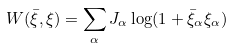<formula> <loc_0><loc_0><loc_500><loc_500>W ( \bar { \xi } , \xi ) = \sum _ { \alpha } J _ { \alpha } \log ( 1 + \bar { \xi } _ { \alpha } \xi _ { \alpha } )</formula> 